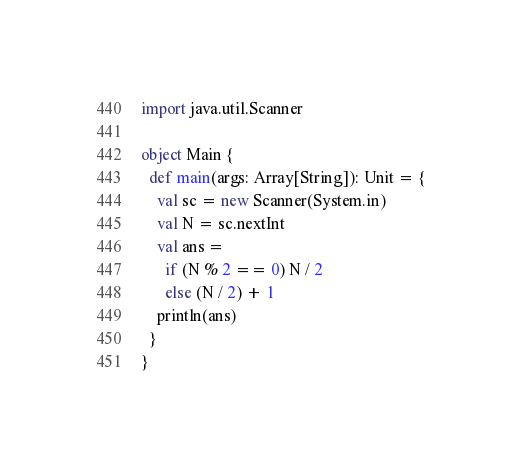Convert code to text. <code><loc_0><loc_0><loc_500><loc_500><_Scala_>import java.util.Scanner

object Main {
  def main(args: Array[String]): Unit = {
    val sc = new Scanner(System.in)
    val N = sc.nextInt
    val ans =
      if (N % 2 == 0) N / 2
      else (N / 2) + 1
    println(ans)
  }
}
</code> 